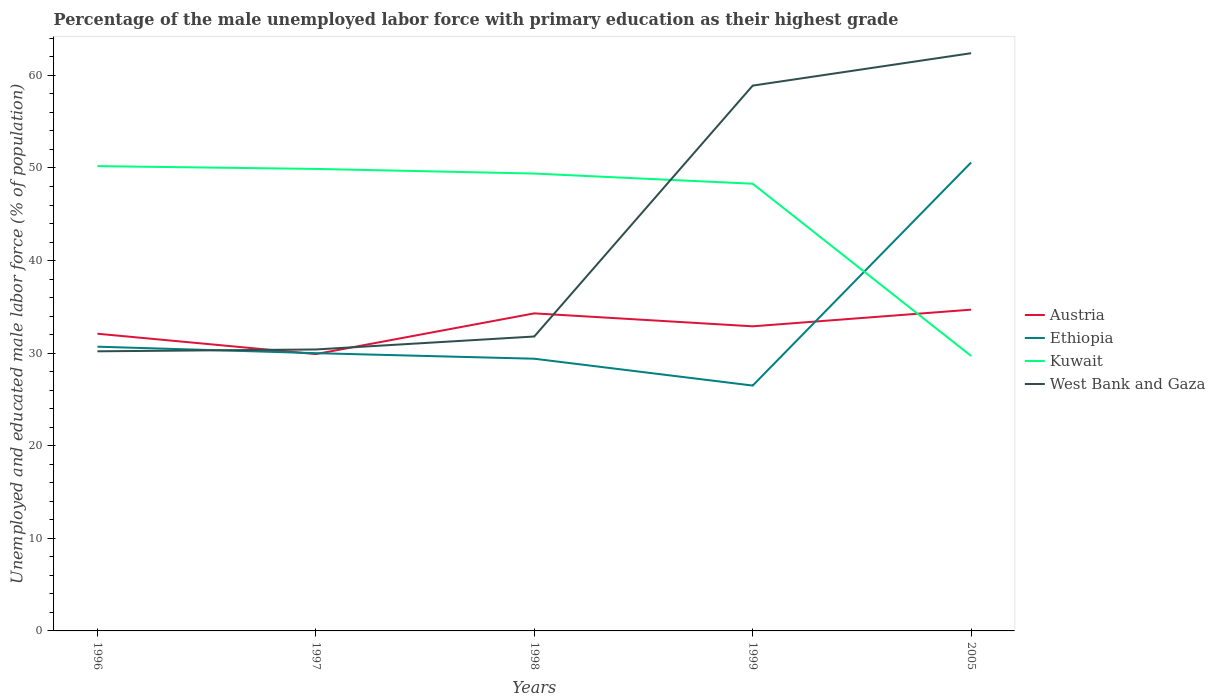How many different coloured lines are there?
Offer a very short reply. 4. Does the line corresponding to West Bank and Gaza intersect with the line corresponding to Kuwait?
Ensure brevity in your answer.  Yes. Is the number of lines equal to the number of legend labels?
Provide a succinct answer. Yes. Across all years, what is the maximum percentage of the unemployed male labor force with primary education in Kuwait?
Give a very brief answer. 29.7. In which year was the percentage of the unemployed male labor force with primary education in Kuwait maximum?
Make the answer very short. 2005. What is the total percentage of the unemployed male labor force with primary education in Ethiopia in the graph?
Offer a terse response. 0.7. What is the difference between the highest and the second highest percentage of the unemployed male labor force with primary education in Austria?
Give a very brief answer. 4.8. What is the difference between the highest and the lowest percentage of the unemployed male labor force with primary education in Kuwait?
Give a very brief answer. 4. Does the graph contain grids?
Your answer should be very brief. No. How many legend labels are there?
Your answer should be very brief. 4. What is the title of the graph?
Ensure brevity in your answer.  Percentage of the male unemployed labor force with primary education as their highest grade. What is the label or title of the X-axis?
Make the answer very short. Years. What is the label or title of the Y-axis?
Offer a terse response. Unemployed and educated male labor force (% of population). What is the Unemployed and educated male labor force (% of population) in Austria in 1996?
Give a very brief answer. 32.1. What is the Unemployed and educated male labor force (% of population) of Ethiopia in 1996?
Ensure brevity in your answer.  30.7. What is the Unemployed and educated male labor force (% of population) of Kuwait in 1996?
Keep it short and to the point. 50.2. What is the Unemployed and educated male labor force (% of population) of West Bank and Gaza in 1996?
Make the answer very short. 30.2. What is the Unemployed and educated male labor force (% of population) of Austria in 1997?
Ensure brevity in your answer.  29.9. What is the Unemployed and educated male labor force (% of population) in Kuwait in 1997?
Make the answer very short. 49.9. What is the Unemployed and educated male labor force (% of population) in West Bank and Gaza in 1997?
Give a very brief answer. 30.4. What is the Unemployed and educated male labor force (% of population) of Austria in 1998?
Offer a terse response. 34.3. What is the Unemployed and educated male labor force (% of population) of Ethiopia in 1998?
Offer a very short reply. 29.4. What is the Unemployed and educated male labor force (% of population) in Kuwait in 1998?
Your response must be concise. 49.4. What is the Unemployed and educated male labor force (% of population) of West Bank and Gaza in 1998?
Keep it short and to the point. 31.8. What is the Unemployed and educated male labor force (% of population) in Austria in 1999?
Your answer should be very brief. 32.9. What is the Unemployed and educated male labor force (% of population) in Ethiopia in 1999?
Provide a short and direct response. 26.5. What is the Unemployed and educated male labor force (% of population) in Kuwait in 1999?
Give a very brief answer. 48.3. What is the Unemployed and educated male labor force (% of population) of West Bank and Gaza in 1999?
Your answer should be very brief. 58.9. What is the Unemployed and educated male labor force (% of population) of Austria in 2005?
Offer a terse response. 34.7. What is the Unemployed and educated male labor force (% of population) in Ethiopia in 2005?
Keep it short and to the point. 50.6. What is the Unemployed and educated male labor force (% of population) of Kuwait in 2005?
Ensure brevity in your answer.  29.7. What is the Unemployed and educated male labor force (% of population) of West Bank and Gaza in 2005?
Give a very brief answer. 62.4. Across all years, what is the maximum Unemployed and educated male labor force (% of population) in Austria?
Ensure brevity in your answer.  34.7. Across all years, what is the maximum Unemployed and educated male labor force (% of population) in Ethiopia?
Your answer should be very brief. 50.6. Across all years, what is the maximum Unemployed and educated male labor force (% of population) in Kuwait?
Make the answer very short. 50.2. Across all years, what is the maximum Unemployed and educated male labor force (% of population) of West Bank and Gaza?
Your answer should be compact. 62.4. Across all years, what is the minimum Unemployed and educated male labor force (% of population) of Austria?
Ensure brevity in your answer.  29.9. Across all years, what is the minimum Unemployed and educated male labor force (% of population) in Ethiopia?
Offer a terse response. 26.5. Across all years, what is the minimum Unemployed and educated male labor force (% of population) of Kuwait?
Make the answer very short. 29.7. Across all years, what is the minimum Unemployed and educated male labor force (% of population) in West Bank and Gaza?
Provide a succinct answer. 30.2. What is the total Unemployed and educated male labor force (% of population) in Austria in the graph?
Keep it short and to the point. 163.9. What is the total Unemployed and educated male labor force (% of population) in Ethiopia in the graph?
Make the answer very short. 167.2. What is the total Unemployed and educated male labor force (% of population) in Kuwait in the graph?
Your answer should be very brief. 227.5. What is the total Unemployed and educated male labor force (% of population) in West Bank and Gaza in the graph?
Your answer should be compact. 213.7. What is the difference between the Unemployed and educated male labor force (% of population) of Austria in 1996 and that in 1997?
Provide a succinct answer. 2.2. What is the difference between the Unemployed and educated male labor force (% of population) of Ethiopia in 1996 and that in 1997?
Offer a terse response. 0.7. What is the difference between the Unemployed and educated male labor force (% of population) of Kuwait in 1996 and that in 1997?
Your response must be concise. 0.3. What is the difference between the Unemployed and educated male labor force (% of population) of Austria in 1996 and that in 1998?
Your response must be concise. -2.2. What is the difference between the Unemployed and educated male labor force (% of population) of Austria in 1996 and that in 1999?
Your answer should be very brief. -0.8. What is the difference between the Unemployed and educated male labor force (% of population) in West Bank and Gaza in 1996 and that in 1999?
Your response must be concise. -28.7. What is the difference between the Unemployed and educated male labor force (% of population) in Austria in 1996 and that in 2005?
Offer a terse response. -2.6. What is the difference between the Unemployed and educated male labor force (% of population) of Ethiopia in 1996 and that in 2005?
Your answer should be very brief. -19.9. What is the difference between the Unemployed and educated male labor force (% of population) of West Bank and Gaza in 1996 and that in 2005?
Your answer should be very brief. -32.2. What is the difference between the Unemployed and educated male labor force (% of population) of Ethiopia in 1997 and that in 1998?
Offer a very short reply. 0.6. What is the difference between the Unemployed and educated male labor force (% of population) of Kuwait in 1997 and that in 1998?
Your answer should be very brief. 0.5. What is the difference between the Unemployed and educated male labor force (% of population) of West Bank and Gaza in 1997 and that in 1998?
Your answer should be compact. -1.4. What is the difference between the Unemployed and educated male labor force (% of population) of Austria in 1997 and that in 1999?
Make the answer very short. -3. What is the difference between the Unemployed and educated male labor force (% of population) in Kuwait in 1997 and that in 1999?
Make the answer very short. 1.6. What is the difference between the Unemployed and educated male labor force (% of population) of West Bank and Gaza in 1997 and that in 1999?
Make the answer very short. -28.5. What is the difference between the Unemployed and educated male labor force (% of population) in Austria in 1997 and that in 2005?
Provide a succinct answer. -4.8. What is the difference between the Unemployed and educated male labor force (% of population) of Ethiopia in 1997 and that in 2005?
Provide a short and direct response. -20.6. What is the difference between the Unemployed and educated male labor force (% of population) of Kuwait in 1997 and that in 2005?
Offer a very short reply. 20.2. What is the difference between the Unemployed and educated male labor force (% of population) of West Bank and Gaza in 1997 and that in 2005?
Your answer should be compact. -32. What is the difference between the Unemployed and educated male labor force (% of population) in Ethiopia in 1998 and that in 1999?
Offer a very short reply. 2.9. What is the difference between the Unemployed and educated male labor force (% of population) in Kuwait in 1998 and that in 1999?
Your answer should be very brief. 1.1. What is the difference between the Unemployed and educated male labor force (% of population) in West Bank and Gaza in 1998 and that in 1999?
Your response must be concise. -27.1. What is the difference between the Unemployed and educated male labor force (% of population) of Austria in 1998 and that in 2005?
Make the answer very short. -0.4. What is the difference between the Unemployed and educated male labor force (% of population) in Ethiopia in 1998 and that in 2005?
Your response must be concise. -21.2. What is the difference between the Unemployed and educated male labor force (% of population) of Kuwait in 1998 and that in 2005?
Make the answer very short. 19.7. What is the difference between the Unemployed and educated male labor force (% of population) in West Bank and Gaza in 1998 and that in 2005?
Give a very brief answer. -30.6. What is the difference between the Unemployed and educated male labor force (% of population) of Austria in 1999 and that in 2005?
Give a very brief answer. -1.8. What is the difference between the Unemployed and educated male labor force (% of population) in Ethiopia in 1999 and that in 2005?
Your response must be concise. -24.1. What is the difference between the Unemployed and educated male labor force (% of population) of Kuwait in 1999 and that in 2005?
Provide a short and direct response. 18.6. What is the difference between the Unemployed and educated male labor force (% of population) in West Bank and Gaza in 1999 and that in 2005?
Offer a terse response. -3.5. What is the difference between the Unemployed and educated male labor force (% of population) in Austria in 1996 and the Unemployed and educated male labor force (% of population) in Kuwait in 1997?
Offer a terse response. -17.8. What is the difference between the Unemployed and educated male labor force (% of population) in Ethiopia in 1996 and the Unemployed and educated male labor force (% of population) in Kuwait in 1997?
Your response must be concise. -19.2. What is the difference between the Unemployed and educated male labor force (% of population) of Kuwait in 1996 and the Unemployed and educated male labor force (% of population) of West Bank and Gaza in 1997?
Provide a short and direct response. 19.8. What is the difference between the Unemployed and educated male labor force (% of population) in Austria in 1996 and the Unemployed and educated male labor force (% of population) in Ethiopia in 1998?
Your response must be concise. 2.7. What is the difference between the Unemployed and educated male labor force (% of population) in Austria in 1996 and the Unemployed and educated male labor force (% of population) in Kuwait in 1998?
Your answer should be very brief. -17.3. What is the difference between the Unemployed and educated male labor force (% of population) in Ethiopia in 1996 and the Unemployed and educated male labor force (% of population) in Kuwait in 1998?
Offer a very short reply. -18.7. What is the difference between the Unemployed and educated male labor force (% of population) of Ethiopia in 1996 and the Unemployed and educated male labor force (% of population) of West Bank and Gaza in 1998?
Provide a short and direct response. -1.1. What is the difference between the Unemployed and educated male labor force (% of population) of Austria in 1996 and the Unemployed and educated male labor force (% of population) of Ethiopia in 1999?
Provide a short and direct response. 5.6. What is the difference between the Unemployed and educated male labor force (% of population) of Austria in 1996 and the Unemployed and educated male labor force (% of population) of Kuwait in 1999?
Give a very brief answer. -16.2. What is the difference between the Unemployed and educated male labor force (% of population) in Austria in 1996 and the Unemployed and educated male labor force (% of population) in West Bank and Gaza in 1999?
Your answer should be very brief. -26.8. What is the difference between the Unemployed and educated male labor force (% of population) of Ethiopia in 1996 and the Unemployed and educated male labor force (% of population) of Kuwait in 1999?
Make the answer very short. -17.6. What is the difference between the Unemployed and educated male labor force (% of population) in Ethiopia in 1996 and the Unemployed and educated male labor force (% of population) in West Bank and Gaza in 1999?
Your answer should be compact. -28.2. What is the difference between the Unemployed and educated male labor force (% of population) in Kuwait in 1996 and the Unemployed and educated male labor force (% of population) in West Bank and Gaza in 1999?
Your answer should be very brief. -8.7. What is the difference between the Unemployed and educated male labor force (% of population) in Austria in 1996 and the Unemployed and educated male labor force (% of population) in Ethiopia in 2005?
Your response must be concise. -18.5. What is the difference between the Unemployed and educated male labor force (% of population) in Austria in 1996 and the Unemployed and educated male labor force (% of population) in West Bank and Gaza in 2005?
Provide a short and direct response. -30.3. What is the difference between the Unemployed and educated male labor force (% of population) of Ethiopia in 1996 and the Unemployed and educated male labor force (% of population) of West Bank and Gaza in 2005?
Make the answer very short. -31.7. What is the difference between the Unemployed and educated male labor force (% of population) in Austria in 1997 and the Unemployed and educated male labor force (% of population) in Ethiopia in 1998?
Give a very brief answer. 0.5. What is the difference between the Unemployed and educated male labor force (% of population) in Austria in 1997 and the Unemployed and educated male labor force (% of population) in Kuwait in 1998?
Ensure brevity in your answer.  -19.5. What is the difference between the Unemployed and educated male labor force (% of population) of Ethiopia in 1997 and the Unemployed and educated male labor force (% of population) of Kuwait in 1998?
Provide a short and direct response. -19.4. What is the difference between the Unemployed and educated male labor force (% of population) of Austria in 1997 and the Unemployed and educated male labor force (% of population) of Kuwait in 1999?
Offer a terse response. -18.4. What is the difference between the Unemployed and educated male labor force (% of population) of Ethiopia in 1997 and the Unemployed and educated male labor force (% of population) of Kuwait in 1999?
Provide a short and direct response. -18.3. What is the difference between the Unemployed and educated male labor force (% of population) of Ethiopia in 1997 and the Unemployed and educated male labor force (% of population) of West Bank and Gaza in 1999?
Your answer should be compact. -28.9. What is the difference between the Unemployed and educated male labor force (% of population) in Kuwait in 1997 and the Unemployed and educated male labor force (% of population) in West Bank and Gaza in 1999?
Ensure brevity in your answer.  -9. What is the difference between the Unemployed and educated male labor force (% of population) of Austria in 1997 and the Unemployed and educated male labor force (% of population) of Ethiopia in 2005?
Your answer should be very brief. -20.7. What is the difference between the Unemployed and educated male labor force (% of population) in Austria in 1997 and the Unemployed and educated male labor force (% of population) in Kuwait in 2005?
Make the answer very short. 0.2. What is the difference between the Unemployed and educated male labor force (% of population) of Austria in 1997 and the Unemployed and educated male labor force (% of population) of West Bank and Gaza in 2005?
Ensure brevity in your answer.  -32.5. What is the difference between the Unemployed and educated male labor force (% of population) of Ethiopia in 1997 and the Unemployed and educated male labor force (% of population) of Kuwait in 2005?
Provide a succinct answer. 0.3. What is the difference between the Unemployed and educated male labor force (% of population) in Ethiopia in 1997 and the Unemployed and educated male labor force (% of population) in West Bank and Gaza in 2005?
Ensure brevity in your answer.  -32.4. What is the difference between the Unemployed and educated male labor force (% of population) in Austria in 1998 and the Unemployed and educated male labor force (% of population) in Ethiopia in 1999?
Give a very brief answer. 7.8. What is the difference between the Unemployed and educated male labor force (% of population) of Austria in 1998 and the Unemployed and educated male labor force (% of population) of West Bank and Gaza in 1999?
Keep it short and to the point. -24.6. What is the difference between the Unemployed and educated male labor force (% of population) in Ethiopia in 1998 and the Unemployed and educated male labor force (% of population) in Kuwait in 1999?
Offer a very short reply. -18.9. What is the difference between the Unemployed and educated male labor force (% of population) in Ethiopia in 1998 and the Unemployed and educated male labor force (% of population) in West Bank and Gaza in 1999?
Your response must be concise. -29.5. What is the difference between the Unemployed and educated male labor force (% of population) in Kuwait in 1998 and the Unemployed and educated male labor force (% of population) in West Bank and Gaza in 1999?
Your answer should be very brief. -9.5. What is the difference between the Unemployed and educated male labor force (% of population) of Austria in 1998 and the Unemployed and educated male labor force (% of population) of Ethiopia in 2005?
Offer a terse response. -16.3. What is the difference between the Unemployed and educated male labor force (% of population) in Austria in 1998 and the Unemployed and educated male labor force (% of population) in West Bank and Gaza in 2005?
Keep it short and to the point. -28.1. What is the difference between the Unemployed and educated male labor force (% of population) of Ethiopia in 1998 and the Unemployed and educated male labor force (% of population) of Kuwait in 2005?
Keep it short and to the point. -0.3. What is the difference between the Unemployed and educated male labor force (% of population) of Ethiopia in 1998 and the Unemployed and educated male labor force (% of population) of West Bank and Gaza in 2005?
Provide a short and direct response. -33. What is the difference between the Unemployed and educated male labor force (% of population) in Kuwait in 1998 and the Unemployed and educated male labor force (% of population) in West Bank and Gaza in 2005?
Offer a very short reply. -13. What is the difference between the Unemployed and educated male labor force (% of population) in Austria in 1999 and the Unemployed and educated male labor force (% of population) in Ethiopia in 2005?
Provide a short and direct response. -17.7. What is the difference between the Unemployed and educated male labor force (% of population) of Austria in 1999 and the Unemployed and educated male labor force (% of population) of West Bank and Gaza in 2005?
Your response must be concise. -29.5. What is the difference between the Unemployed and educated male labor force (% of population) in Ethiopia in 1999 and the Unemployed and educated male labor force (% of population) in West Bank and Gaza in 2005?
Provide a succinct answer. -35.9. What is the difference between the Unemployed and educated male labor force (% of population) of Kuwait in 1999 and the Unemployed and educated male labor force (% of population) of West Bank and Gaza in 2005?
Offer a very short reply. -14.1. What is the average Unemployed and educated male labor force (% of population) in Austria per year?
Offer a very short reply. 32.78. What is the average Unemployed and educated male labor force (% of population) of Ethiopia per year?
Keep it short and to the point. 33.44. What is the average Unemployed and educated male labor force (% of population) of Kuwait per year?
Keep it short and to the point. 45.5. What is the average Unemployed and educated male labor force (% of population) in West Bank and Gaza per year?
Ensure brevity in your answer.  42.74. In the year 1996, what is the difference between the Unemployed and educated male labor force (% of population) in Austria and Unemployed and educated male labor force (% of population) in Kuwait?
Provide a short and direct response. -18.1. In the year 1996, what is the difference between the Unemployed and educated male labor force (% of population) in Ethiopia and Unemployed and educated male labor force (% of population) in Kuwait?
Provide a short and direct response. -19.5. In the year 1996, what is the difference between the Unemployed and educated male labor force (% of population) in Kuwait and Unemployed and educated male labor force (% of population) in West Bank and Gaza?
Provide a short and direct response. 20. In the year 1997, what is the difference between the Unemployed and educated male labor force (% of population) in Austria and Unemployed and educated male labor force (% of population) in Ethiopia?
Provide a succinct answer. -0.1. In the year 1997, what is the difference between the Unemployed and educated male labor force (% of population) of Austria and Unemployed and educated male labor force (% of population) of Kuwait?
Provide a succinct answer. -20. In the year 1997, what is the difference between the Unemployed and educated male labor force (% of population) in Ethiopia and Unemployed and educated male labor force (% of population) in Kuwait?
Offer a terse response. -19.9. In the year 1998, what is the difference between the Unemployed and educated male labor force (% of population) in Austria and Unemployed and educated male labor force (% of population) in Kuwait?
Make the answer very short. -15.1. In the year 1998, what is the difference between the Unemployed and educated male labor force (% of population) of Kuwait and Unemployed and educated male labor force (% of population) of West Bank and Gaza?
Your response must be concise. 17.6. In the year 1999, what is the difference between the Unemployed and educated male labor force (% of population) in Austria and Unemployed and educated male labor force (% of population) in Ethiopia?
Provide a short and direct response. 6.4. In the year 1999, what is the difference between the Unemployed and educated male labor force (% of population) in Austria and Unemployed and educated male labor force (% of population) in Kuwait?
Give a very brief answer. -15.4. In the year 1999, what is the difference between the Unemployed and educated male labor force (% of population) in Ethiopia and Unemployed and educated male labor force (% of population) in Kuwait?
Offer a terse response. -21.8. In the year 1999, what is the difference between the Unemployed and educated male labor force (% of population) in Ethiopia and Unemployed and educated male labor force (% of population) in West Bank and Gaza?
Your answer should be very brief. -32.4. In the year 1999, what is the difference between the Unemployed and educated male labor force (% of population) in Kuwait and Unemployed and educated male labor force (% of population) in West Bank and Gaza?
Make the answer very short. -10.6. In the year 2005, what is the difference between the Unemployed and educated male labor force (% of population) in Austria and Unemployed and educated male labor force (% of population) in Ethiopia?
Give a very brief answer. -15.9. In the year 2005, what is the difference between the Unemployed and educated male labor force (% of population) in Austria and Unemployed and educated male labor force (% of population) in Kuwait?
Provide a short and direct response. 5. In the year 2005, what is the difference between the Unemployed and educated male labor force (% of population) in Austria and Unemployed and educated male labor force (% of population) in West Bank and Gaza?
Provide a short and direct response. -27.7. In the year 2005, what is the difference between the Unemployed and educated male labor force (% of population) of Ethiopia and Unemployed and educated male labor force (% of population) of Kuwait?
Provide a succinct answer. 20.9. In the year 2005, what is the difference between the Unemployed and educated male labor force (% of population) in Kuwait and Unemployed and educated male labor force (% of population) in West Bank and Gaza?
Give a very brief answer. -32.7. What is the ratio of the Unemployed and educated male labor force (% of population) of Austria in 1996 to that in 1997?
Your response must be concise. 1.07. What is the ratio of the Unemployed and educated male labor force (% of population) in Ethiopia in 1996 to that in 1997?
Your response must be concise. 1.02. What is the ratio of the Unemployed and educated male labor force (% of population) in Kuwait in 1996 to that in 1997?
Give a very brief answer. 1.01. What is the ratio of the Unemployed and educated male labor force (% of population) of West Bank and Gaza in 1996 to that in 1997?
Ensure brevity in your answer.  0.99. What is the ratio of the Unemployed and educated male labor force (% of population) of Austria in 1996 to that in 1998?
Offer a very short reply. 0.94. What is the ratio of the Unemployed and educated male labor force (% of population) of Ethiopia in 1996 to that in 1998?
Provide a succinct answer. 1.04. What is the ratio of the Unemployed and educated male labor force (% of population) of Kuwait in 1996 to that in 1998?
Offer a terse response. 1.02. What is the ratio of the Unemployed and educated male labor force (% of population) of West Bank and Gaza in 1996 to that in 1998?
Provide a succinct answer. 0.95. What is the ratio of the Unemployed and educated male labor force (% of population) of Austria in 1996 to that in 1999?
Provide a succinct answer. 0.98. What is the ratio of the Unemployed and educated male labor force (% of population) in Ethiopia in 1996 to that in 1999?
Your response must be concise. 1.16. What is the ratio of the Unemployed and educated male labor force (% of population) in Kuwait in 1996 to that in 1999?
Offer a very short reply. 1.04. What is the ratio of the Unemployed and educated male labor force (% of population) in West Bank and Gaza in 1996 to that in 1999?
Your answer should be very brief. 0.51. What is the ratio of the Unemployed and educated male labor force (% of population) of Austria in 1996 to that in 2005?
Provide a short and direct response. 0.93. What is the ratio of the Unemployed and educated male labor force (% of population) of Ethiopia in 1996 to that in 2005?
Provide a succinct answer. 0.61. What is the ratio of the Unemployed and educated male labor force (% of population) of Kuwait in 1996 to that in 2005?
Ensure brevity in your answer.  1.69. What is the ratio of the Unemployed and educated male labor force (% of population) of West Bank and Gaza in 1996 to that in 2005?
Give a very brief answer. 0.48. What is the ratio of the Unemployed and educated male labor force (% of population) of Austria in 1997 to that in 1998?
Ensure brevity in your answer.  0.87. What is the ratio of the Unemployed and educated male labor force (% of population) in Ethiopia in 1997 to that in 1998?
Provide a succinct answer. 1.02. What is the ratio of the Unemployed and educated male labor force (% of population) of West Bank and Gaza in 1997 to that in 1998?
Give a very brief answer. 0.96. What is the ratio of the Unemployed and educated male labor force (% of population) of Austria in 1997 to that in 1999?
Give a very brief answer. 0.91. What is the ratio of the Unemployed and educated male labor force (% of population) of Ethiopia in 1997 to that in 1999?
Your response must be concise. 1.13. What is the ratio of the Unemployed and educated male labor force (% of population) of Kuwait in 1997 to that in 1999?
Give a very brief answer. 1.03. What is the ratio of the Unemployed and educated male labor force (% of population) of West Bank and Gaza in 1997 to that in 1999?
Offer a very short reply. 0.52. What is the ratio of the Unemployed and educated male labor force (% of population) in Austria in 1997 to that in 2005?
Give a very brief answer. 0.86. What is the ratio of the Unemployed and educated male labor force (% of population) in Ethiopia in 1997 to that in 2005?
Provide a succinct answer. 0.59. What is the ratio of the Unemployed and educated male labor force (% of population) of Kuwait in 1997 to that in 2005?
Provide a succinct answer. 1.68. What is the ratio of the Unemployed and educated male labor force (% of population) of West Bank and Gaza in 1997 to that in 2005?
Provide a succinct answer. 0.49. What is the ratio of the Unemployed and educated male labor force (% of population) in Austria in 1998 to that in 1999?
Your answer should be very brief. 1.04. What is the ratio of the Unemployed and educated male labor force (% of population) in Ethiopia in 1998 to that in 1999?
Offer a very short reply. 1.11. What is the ratio of the Unemployed and educated male labor force (% of population) of Kuwait in 1998 to that in 1999?
Ensure brevity in your answer.  1.02. What is the ratio of the Unemployed and educated male labor force (% of population) of West Bank and Gaza in 1998 to that in 1999?
Offer a very short reply. 0.54. What is the ratio of the Unemployed and educated male labor force (% of population) of Austria in 1998 to that in 2005?
Your response must be concise. 0.99. What is the ratio of the Unemployed and educated male labor force (% of population) in Ethiopia in 1998 to that in 2005?
Your response must be concise. 0.58. What is the ratio of the Unemployed and educated male labor force (% of population) in Kuwait in 1998 to that in 2005?
Provide a short and direct response. 1.66. What is the ratio of the Unemployed and educated male labor force (% of population) in West Bank and Gaza in 1998 to that in 2005?
Give a very brief answer. 0.51. What is the ratio of the Unemployed and educated male labor force (% of population) in Austria in 1999 to that in 2005?
Offer a terse response. 0.95. What is the ratio of the Unemployed and educated male labor force (% of population) in Ethiopia in 1999 to that in 2005?
Keep it short and to the point. 0.52. What is the ratio of the Unemployed and educated male labor force (% of population) in Kuwait in 1999 to that in 2005?
Ensure brevity in your answer.  1.63. What is the ratio of the Unemployed and educated male labor force (% of population) in West Bank and Gaza in 1999 to that in 2005?
Your answer should be compact. 0.94. What is the difference between the highest and the lowest Unemployed and educated male labor force (% of population) of Austria?
Make the answer very short. 4.8. What is the difference between the highest and the lowest Unemployed and educated male labor force (% of population) in Ethiopia?
Give a very brief answer. 24.1. What is the difference between the highest and the lowest Unemployed and educated male labor force (% of population) of Kuwait?
Give a very brief answer. 20.5. What is the difference between the highest and the lowest Unemployed and educated male labor force (% of population) in West Bank and Gaza?
Your answer should be very brief. 32.2. 